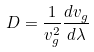Convert formula to latex. <formula><loc_0><loc_0><loc_500><loc_500>D = \frac { 1 } { v _ { g } ^ { 2 } } \frac { d v _ { g } } { d \lambda }</formula> 